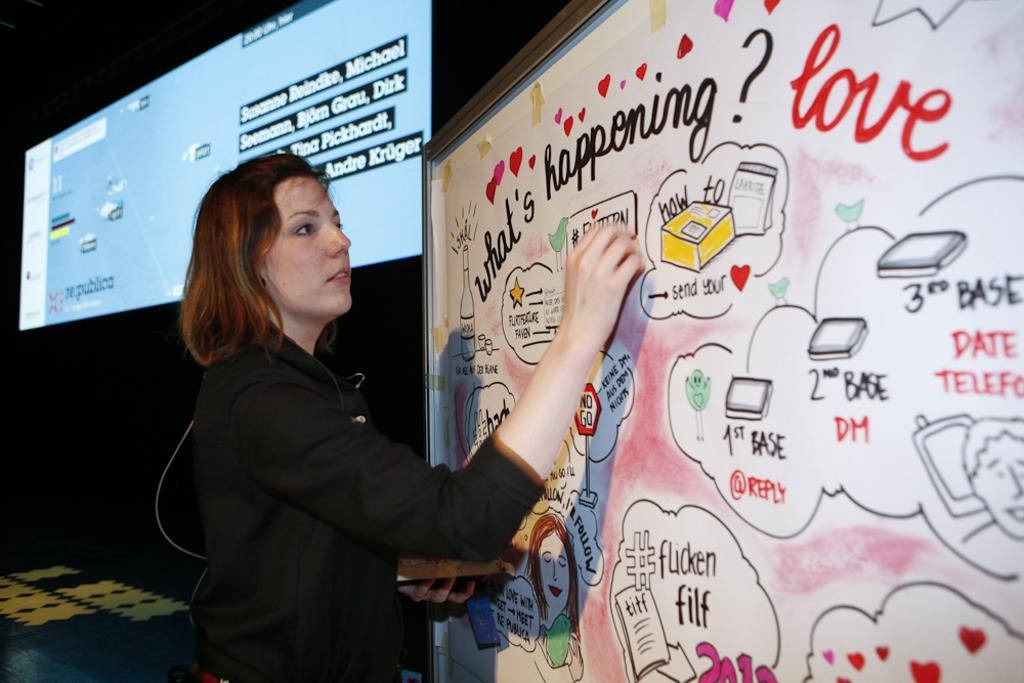<image>
Provide a brief description of the given image. A woman is writing on a white board that has hearts and an overall theme of love written on it. 